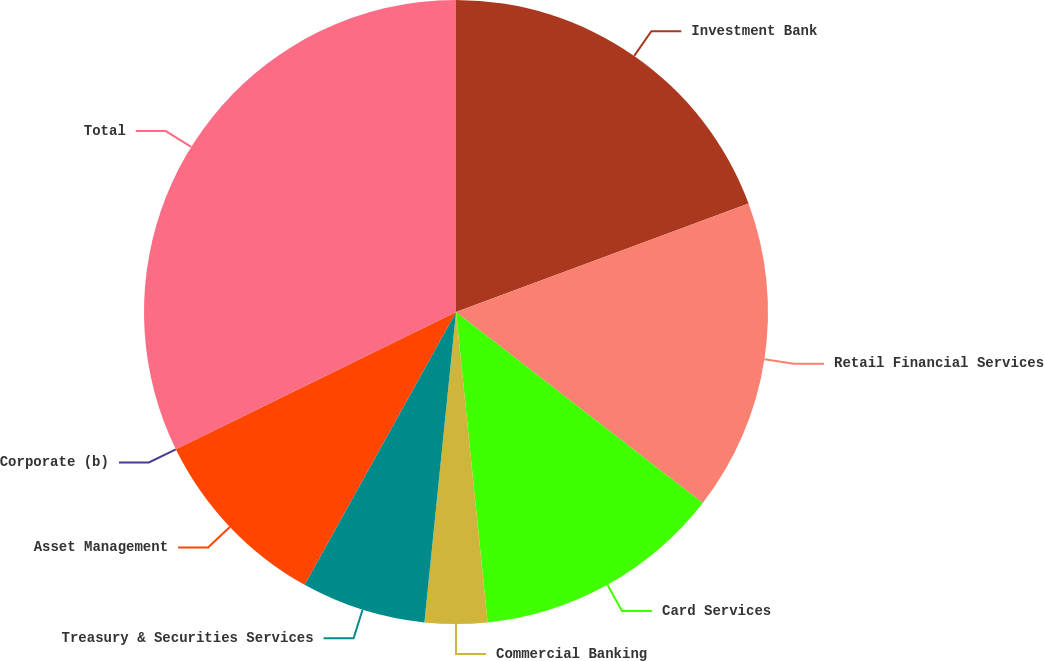<chart> <loc_0><loc_0><loc_500><loc_500><pie_chart><fcel>Investment Bank<fcel>Retail Financial Services<fcel>Card Services<fcel>Commercial Banking<fcel>Treasury & Securities Services<fcel>Asset Management<fcel>Corporate (b)<fcel>Total<nl><fcel>19.35%<fcel>16.13%<fcel>12.9%<fcel>3.23%<fcel>6.45%<fcel>9.68%<fcel>0.0%<fcel>32.25%<nl></chart> 